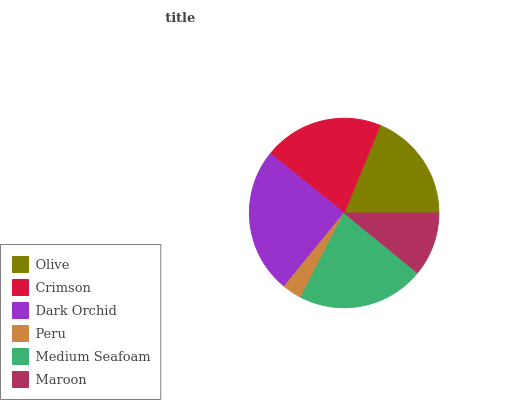Is Peru the minimum?
Answer yes or no. Yes. Is Dark Orchid the maximum?
Answer yes or no. Yes. Is Crimson the minimum?
Answer yes or no. No. Is Crimson the maximum?
Answer yes or no. No. Is Crimson greater than Olive?
Answer yes or no. Yes. Is Olive less than Crimson?
Answer yes or no. Yes. Is Olive greater than Crimson?
Answer yes or no. No. Is Crimson less than Olive?
Answer yes or no. No. Is Crimson the high median?
Answer yes or no. Yes. Is Olive the low median?
Answer yes or no. Yes. Is Peru the high median?
Answer yes or no. No. Is Peru the low median?
Answer yes or no. No. 